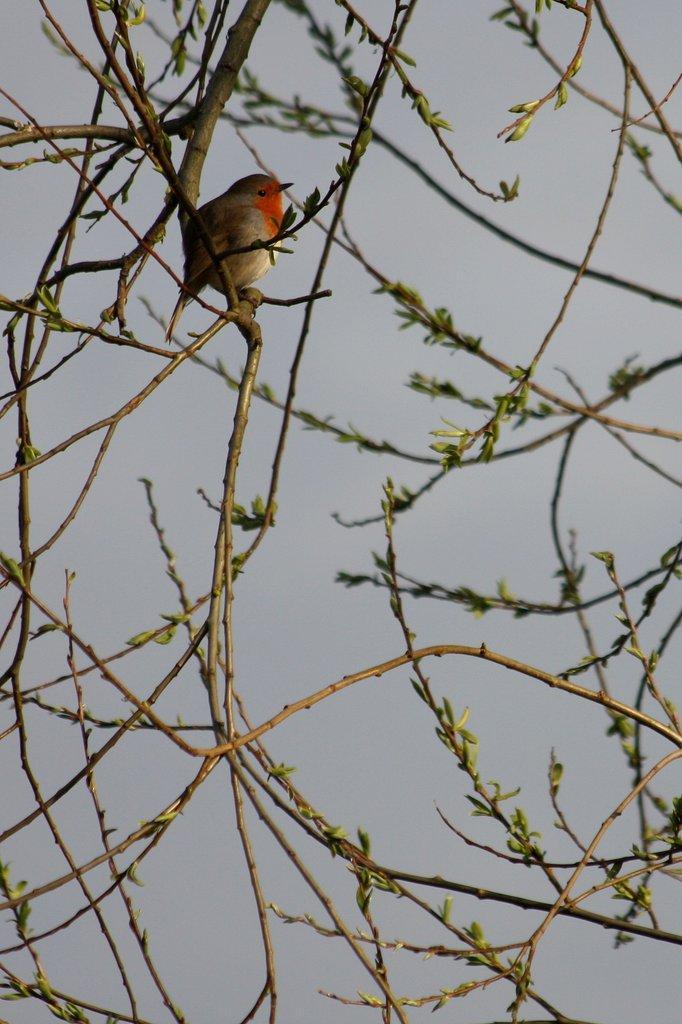How would you summarize this image in a sentence or two? Here in this picture we can see a bird present on the branches of a plant over there. 